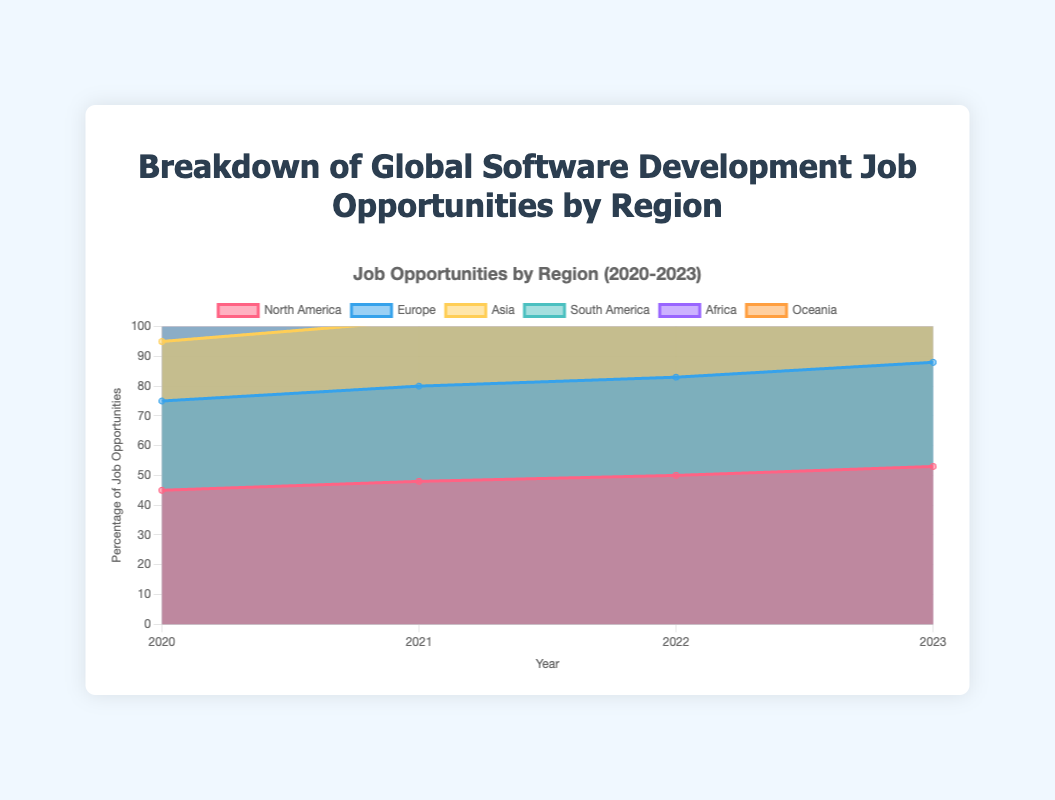Who has the highest job opportunities among the regions in 2023? From the area chart, the segment with the highest percentage in 2023 is North America. By looking at the end of the chart, North America is at the topmost position.
Answer: North America Which region has seen a consistent increase in job opportunities from 2020 to 2023? Looking at the area chart, North America, Europe, Asia, South America, Africa, and Oceania all show an upward trend from 2020 to 2023, indicating consistent increases.
Answer: All regions (North America, Europe, Asia, South America, Africa, Oceania) What is the title of the chart? The title is usually displayed at the top of the figure. In this chart, the title is "Breakdown of Global Software Development Job Opportunities by Region."
Answer: Breakdown of Global Software Development Job Opportunities by Region How did the job opportunities in Africa change from 2020 to 2023? By examining the Africa area on the chart from 2020 to 2023, it starts at 5% in 2020 and increases to 9% in 2023, indicating a rise.
Answer: Increased from 5% to 9% What is the combined job opportunity percentage for North America and Europe in 2022? Looking at the chart for 2022, North America and Europe have 50% and 33% respectively. Adding these together gives 50% + 33% = 83%.
Answer: 83% Which regions had the smallest increase in job opportunities from 2020 to 2023? By comparing the size of the areas from 2020 to 2023 for each region, Oceania increased from 3% to 6%, revealing the smallest absolute increase of 3 percentage points.
Answer: Oceania What is the percentage increase in job opportunities for Asia from 2020 to 2023? In 2020, Asia is at 20%, and by 2023, it is at 26%. The percentage increase can be calculated as (26-20)/20 * 100 = 30%.
Answer: 30% Which year had the largest total increase in job opportunities across all regions? By examining the chart, each year's total increase can be seen through the cumulative height. The most noticeable total increase is from 2020 to 2021.
Answer: 2021 What trends can you observe in overall job opportunities for all regions from 2020 to 2023? The stacked area chart shows all regions experiencing a consistent increase in job opportunities, reflecting an overall uptrend globally.
Answer: Consistent increase Which region has the second-largest job opportunity share in 2023? From the stacked area chart, after North America, Europe has the second-largest area in 2023.
Answer: Europe 